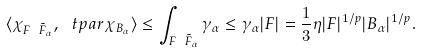<formula> <loc_0><loc_0><loc_500><loc_500>\langle \chi _ { F \ \tilde { F } _ { \alpha } } , \, \ t p a r \chi _ { B _ { \alpha } } \rangle \leq \int _ { F \ \tilde { F } _ { \alpha } } \gamma _ { \alpha } \leq \gamma _ { \alpha } | F | = \frac { 1 } { 3 } \eta | F | ^ { 1 / p } | B _ { \alpha } | ^ { 1 / p } .</formula> 